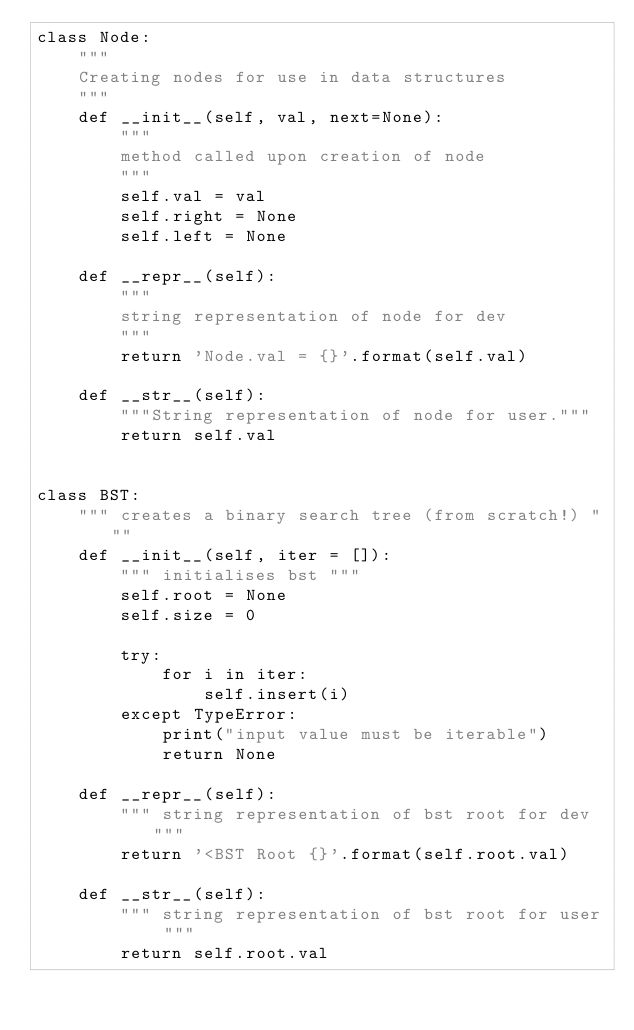Convert code to text. <code><loc_0><loc_0><loc_500><loc_500><_Python_>class Node:
    """
    Creating nodes for use in data structures
    """
    def __init__(self, val, next=None):
        """
        method called upon creation of node
        """
        self.val = val
        self.right = None
        self.left = None

    def __repr__(self):
        """
        string representation of node for dev
        """
        return 'Node.val = {}'.format(self.val)

    def __str__(self):
        """String representation of node for user."""
        return self.val


class BST:
    """ creates a binary search tree (from scratch!) """
    def __init__(self, iter = []):
        """ initialises bst """
        self.root = None
        self.size = 0

        try:
            for i in iter:
                self.insert(i)
        except TypeError:
            print("input value must be iterable")
            return None
        
    def __repr__(self):
        """ string representation of bst root for dev """
        return '<BST Root {}'.format(self.root.val)
    
    def __str__(self):
        """ string representation of bst root for user """
        return self.root.val
    </code> 